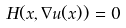<formula> <loc_0><loc_0><loc_500><loc_500>H ( x , \nabla u ( x ) ) = 0</formula> 